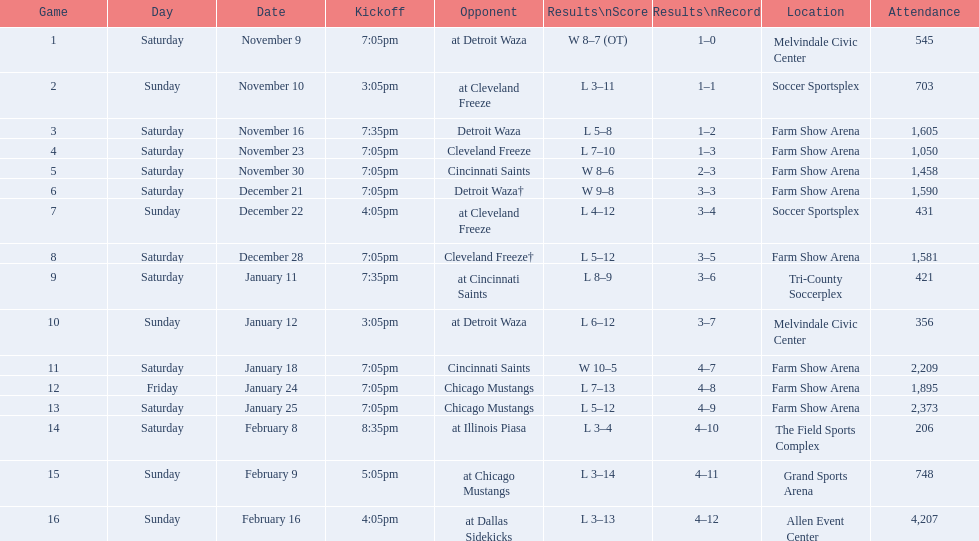In how many occasions did the team play at home yet failed to win? 5. 